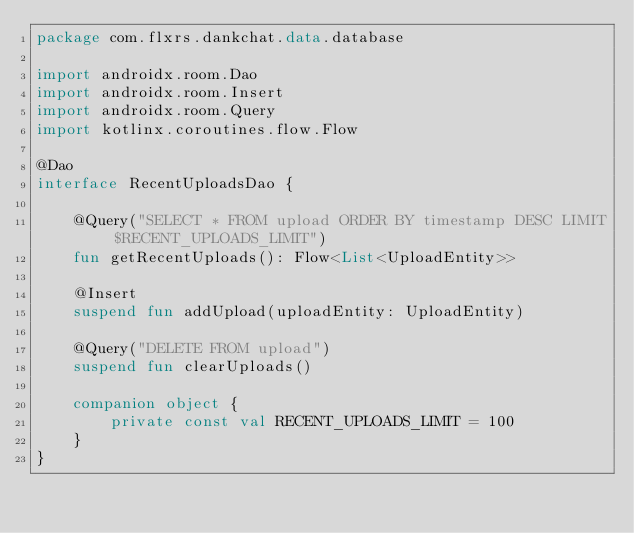Convert code to text. <code><loc_0><loc_0><loc_500><loc_500><_Kotlin_>package com.flxrs.dankchat.data.database

import androidx.room.Dao
import androidx.room.Insert
import androidx.room.Query
import kotlinx.coroutines.flow.Flow

@Dao
interface RecentUploadsDao {

    @Query("SELECT * FROM upload ORDER BY timestamp DESC LIMIT $RECENT_UPLOADS_LIMIT")
    fun getRecentUploads(): Flow<List<UploadEntity>>

    @Insert
    suspend fun addUpload(uploadEntity: UploadEntity)

    @Query("DELETE FROM upload")
    suspend fun clearUploads()

    companion object {
        private const val RECENT_UPLOADS_LIMIT = 100
    }
}</code> 